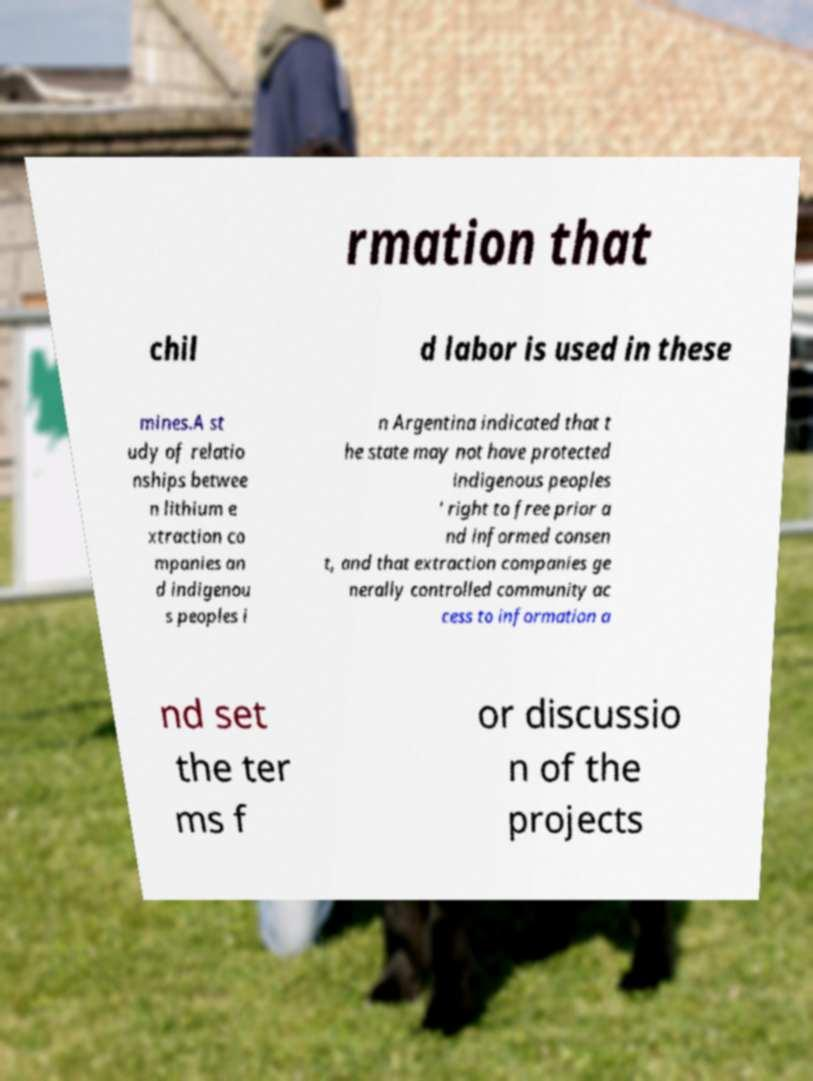For documentation purposes, I need the text within this image transcribed. Could you provide that? rmation that chil d labor is used in these mines.A st udy of relatio nships betwee n lithium e xtraction co mpanies an d indigenou s peoples i n Argentina indicated that t he state may not have protected indigenous peoples ' right to free prior a nd informed consen t, and that extraction companies ge nerally controlled community ac cess to information a nd set the ter ms f or discussio n of the projects 